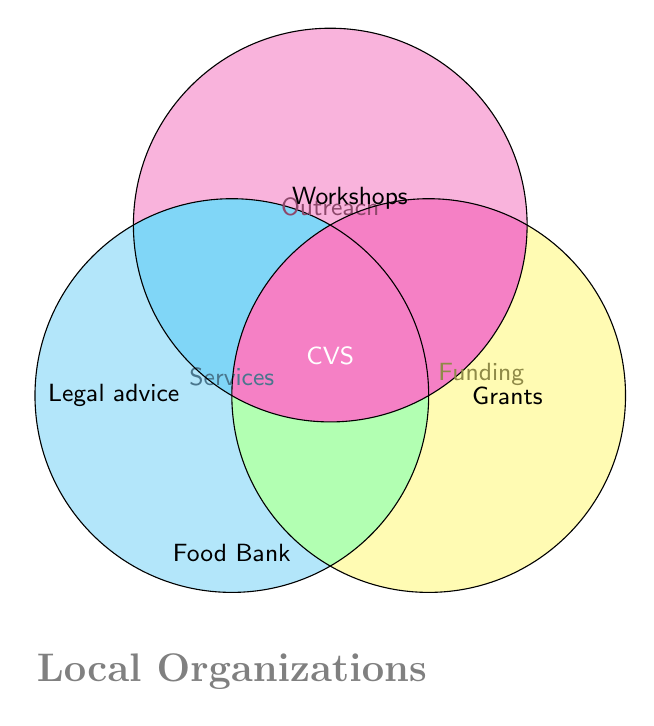What are the three main categories represented in the Venn Diagram? The diagram shows three overlapping circles, each labeled differently: 'Services', 'Outreach', and 'Funding'
Answer: Services, Outreach, Funding Which organization offers 'Legal advice'? 'Legal advice' is mentioned within the 'Services' circle
Answer: Citizens Advice Where are 'Community workshops' represented in the figure? 'Community workshops' are shown within the circle labeled 'Outreach'
Answer: Outreach What category does 'Government grants' belong to? 'Government grants' are shown within the circle labeled 'Funding'
Answer: Funding How many organizations are mentioned in the entire figure? There are specific mentions of Citizens Advice, CVS, and Food Bank within the circles
Answer: Three What organization is linked to all three categories? The organization listed at the center where all three circles overlap is CVS
Answer: CVS Which organizations provide some type of support and belong to any category involving 'Outreach'? Citizens Advice (Workshops), Council for Voluntary Service (CVS), and others implicitly involved in Outreach but only these two are textually represented
Answer: Citizens Advice, CVS Compare the categories providing 'Legal advice' and 'Food Bank services' 'Legal advice' falls only under Services, while 'Food Bank services' falls under a general mention, not within a single circle
Answer: Legal advice falls under Services only, Food Bank is general What organizations overlap between 'Services' and 'Outreach'? Based on the shared section of 'Services' and 'Outreach', only 'Community workshops' for Citizens Advice and CVS are related
Answer: Citizens Advice, CVS Explain the overlapping area including Outreach and Funding but not Services Overlapping areas between Outreach and Funding are represented but with no specific labels directly placed there. However, it would include partnerships such as Pro bono clinics and some like CVS indirectly
Answer: Pro bono clinics (implied), CVS (implied) 